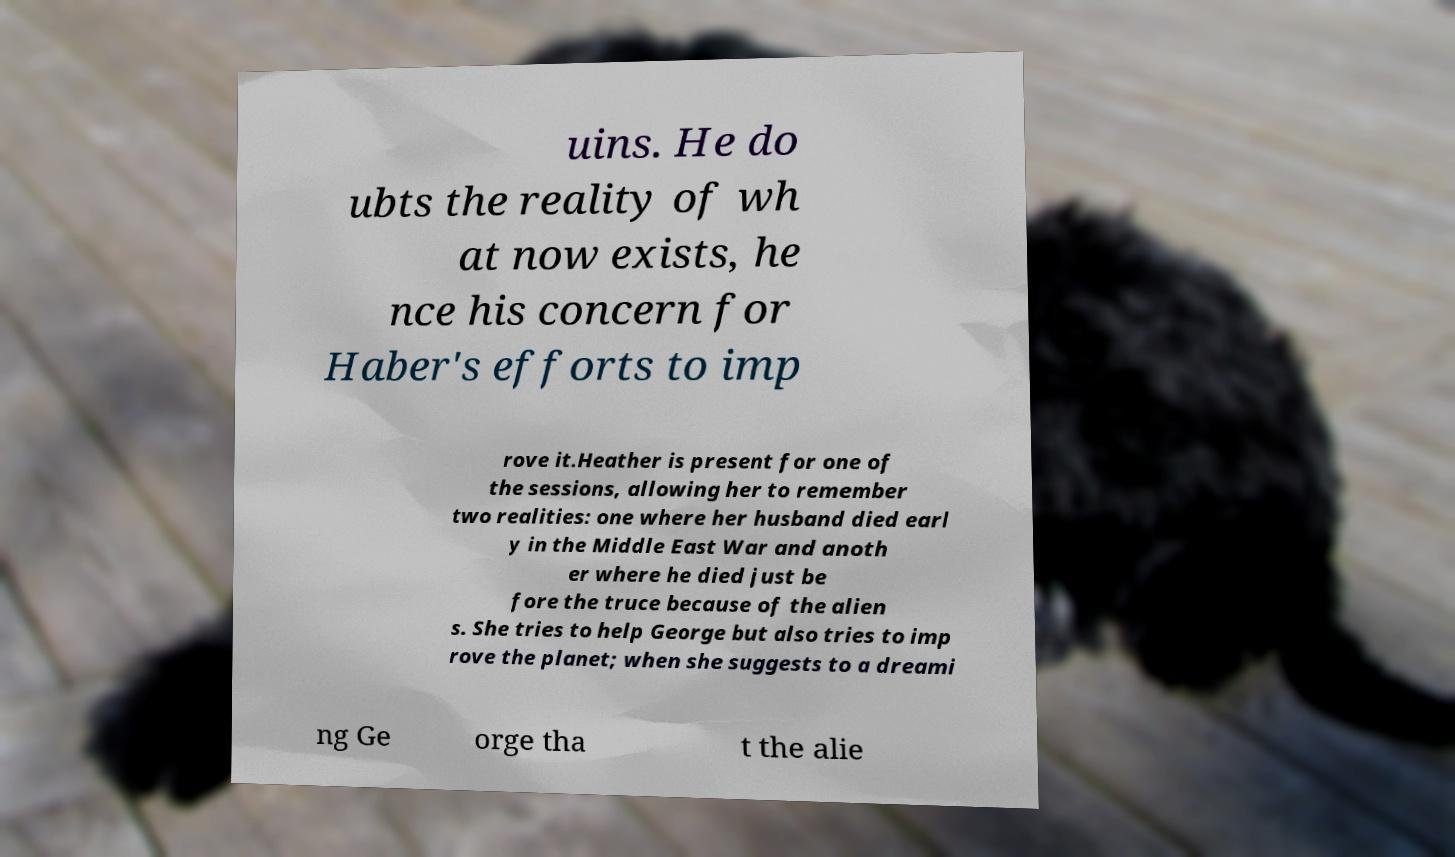Could you assist in decoding the text presented in this image and type it out clearly? uins. He do ubts the reality of wh at now exists, he nce his concern for Haber's efforts to imp rove it.Heather is present for one of the sessions, allowing her to remember two realities: one where her husband died earl y in the Middle East War and anoth er where he died just be fore the truce because of the alien s. She tries to help George but also tries to imp rove the planet; when she suggests to a dreami ng Ge orge tha t the alie 